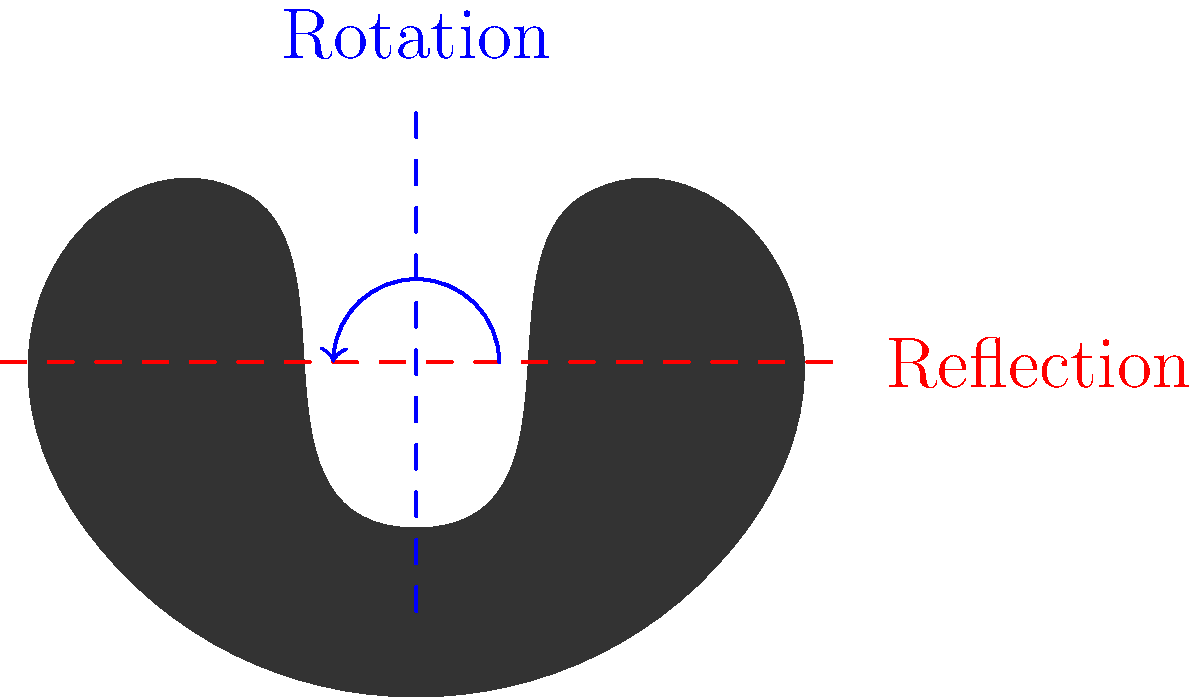In the iconic hairstyle of Sigourney Weaver's character Ripley from "Alien," which symmetry operations are present, and what is the order of the rotation group for this hairstyle? To analyze the symmetry operations of Sigourney Weaver's iconic hairstyle in "Alien," we need to consider the following steps:

1. Reflection symmetry:
   - The hairstyle has a vertical line of symmetry (shown in red).
   - This means we can reflect the hairstyle across this line, and it will look the same.

2. Rotational symmetry:
   - The hairstyle has 2-fold rotational symmetry (shown in blue).
   - This means we can rotate the hairstyle by 180° (or π radians) around its center, and it will look the same.

3. Order of the rotation group:
   - The order of a rotation group is the number of distinct rotations that leave the object unchanged.
   - In this case, we have two distinct rotations:
     a) Identity (0° or 360° rotation)
     b) 180° rotation
   - Therefore, the order of the rotation group is 2.

4. Symmetry group:
   - The complete symmetry group of this hairstyle includes both reflections and rotations.
   - It is known as the Dihedral group D₂, which has 4 elements:
     a) Identity
     b) 180° rotation
     c) Reflection across the vertical axis
     d) Reflection across the horizontal axis (equivalent to a 180° rotation followed by a vertical reflection)

In group theory, this symmetry group is isomorphic to the Klein four-group (V₄ or Z₂ × Z₂).
Answer: Reflection, 2-fold rotation; order 2 